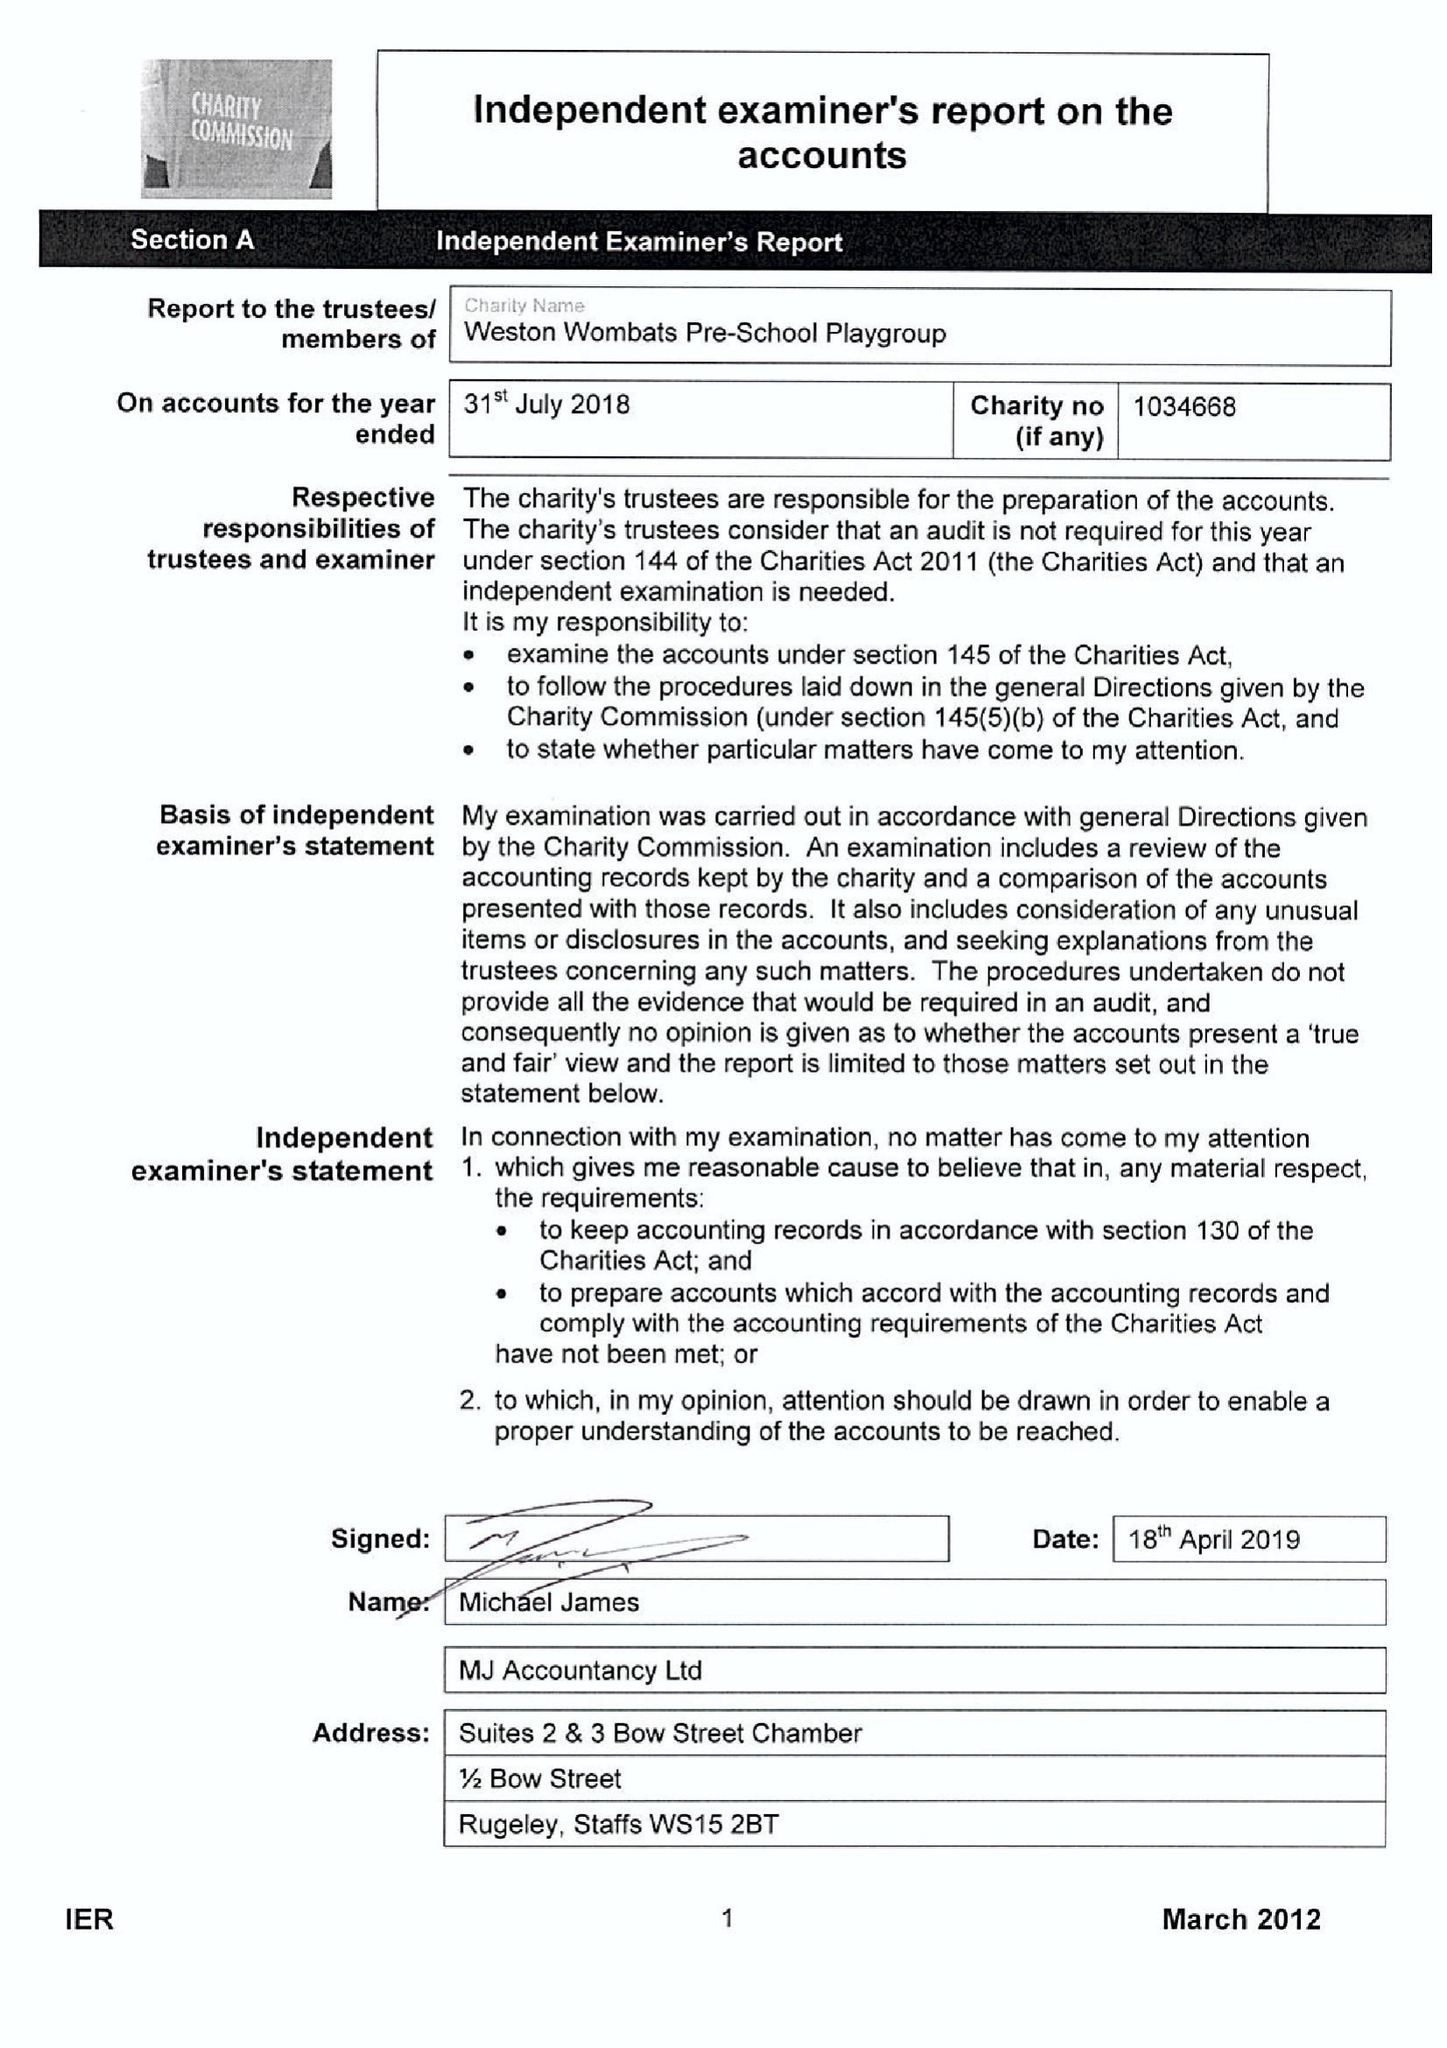What is the value for the charity_number?
Answer the question using a single word or phrase. 1034668 